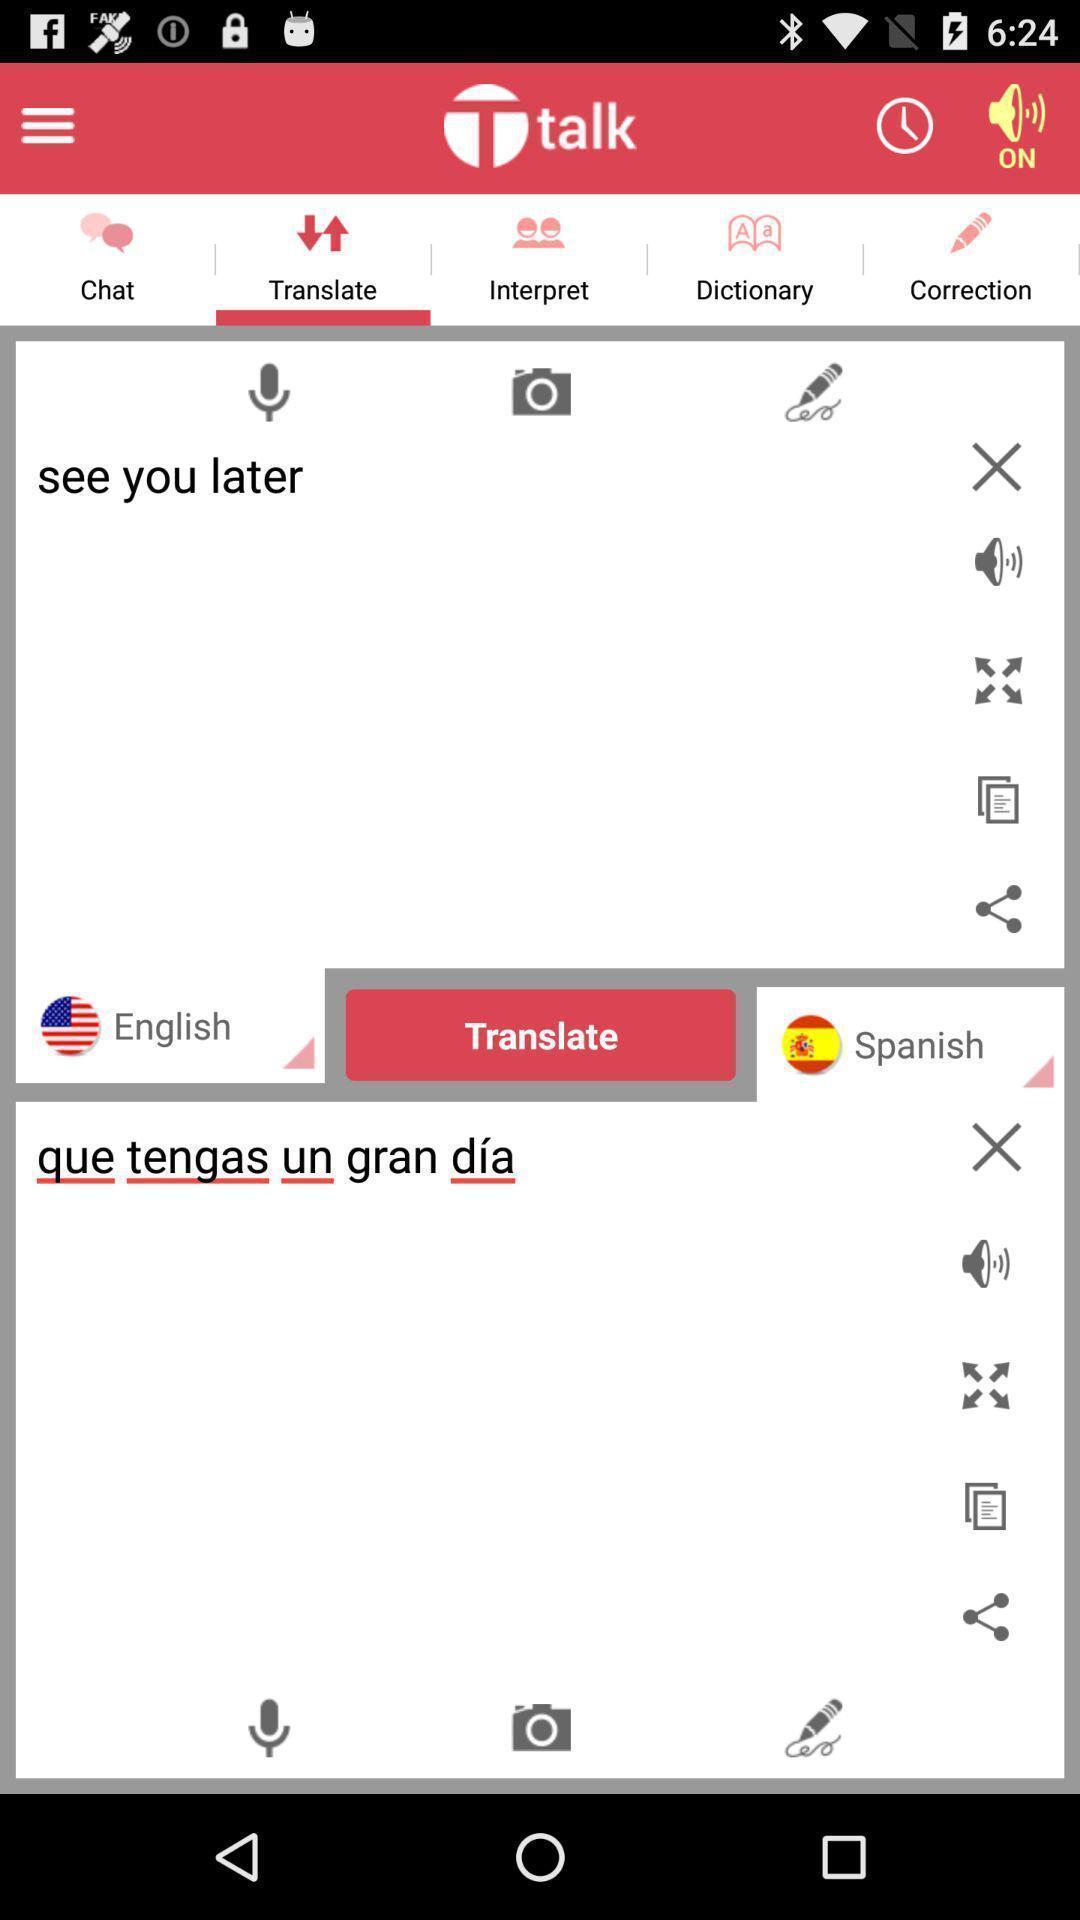Summarize the information in this screenshot. Translation page with two languages. 